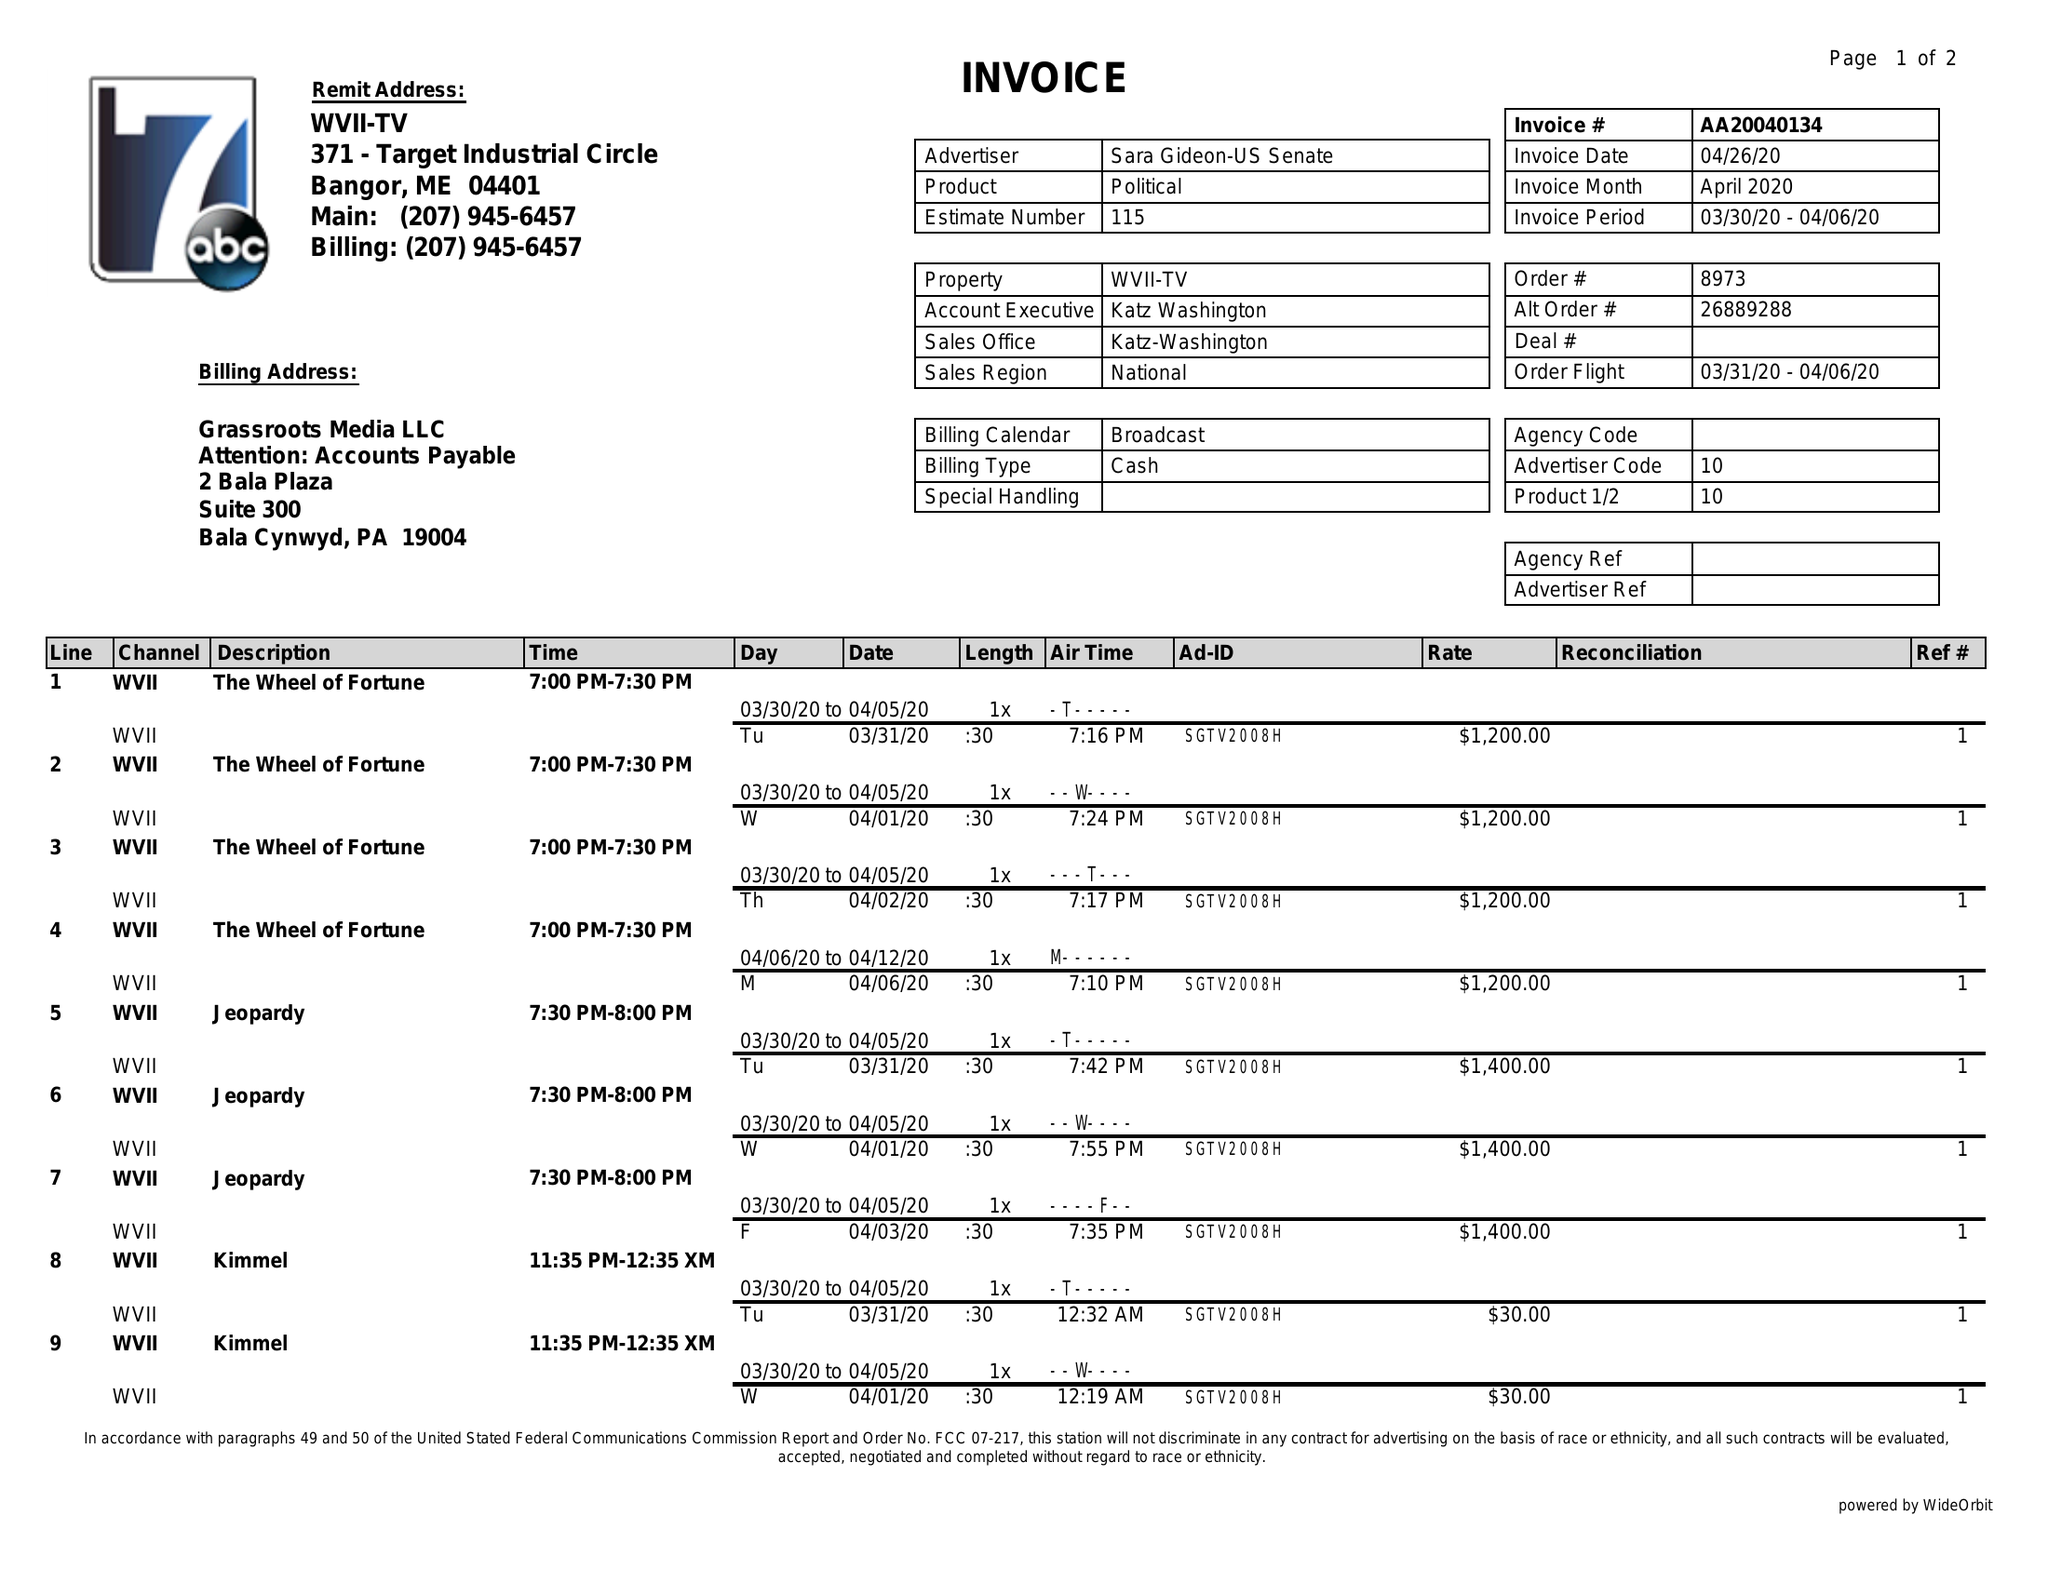What is the value for the gross_amount?
Answer the question using a single word or phrase. 9510.00 